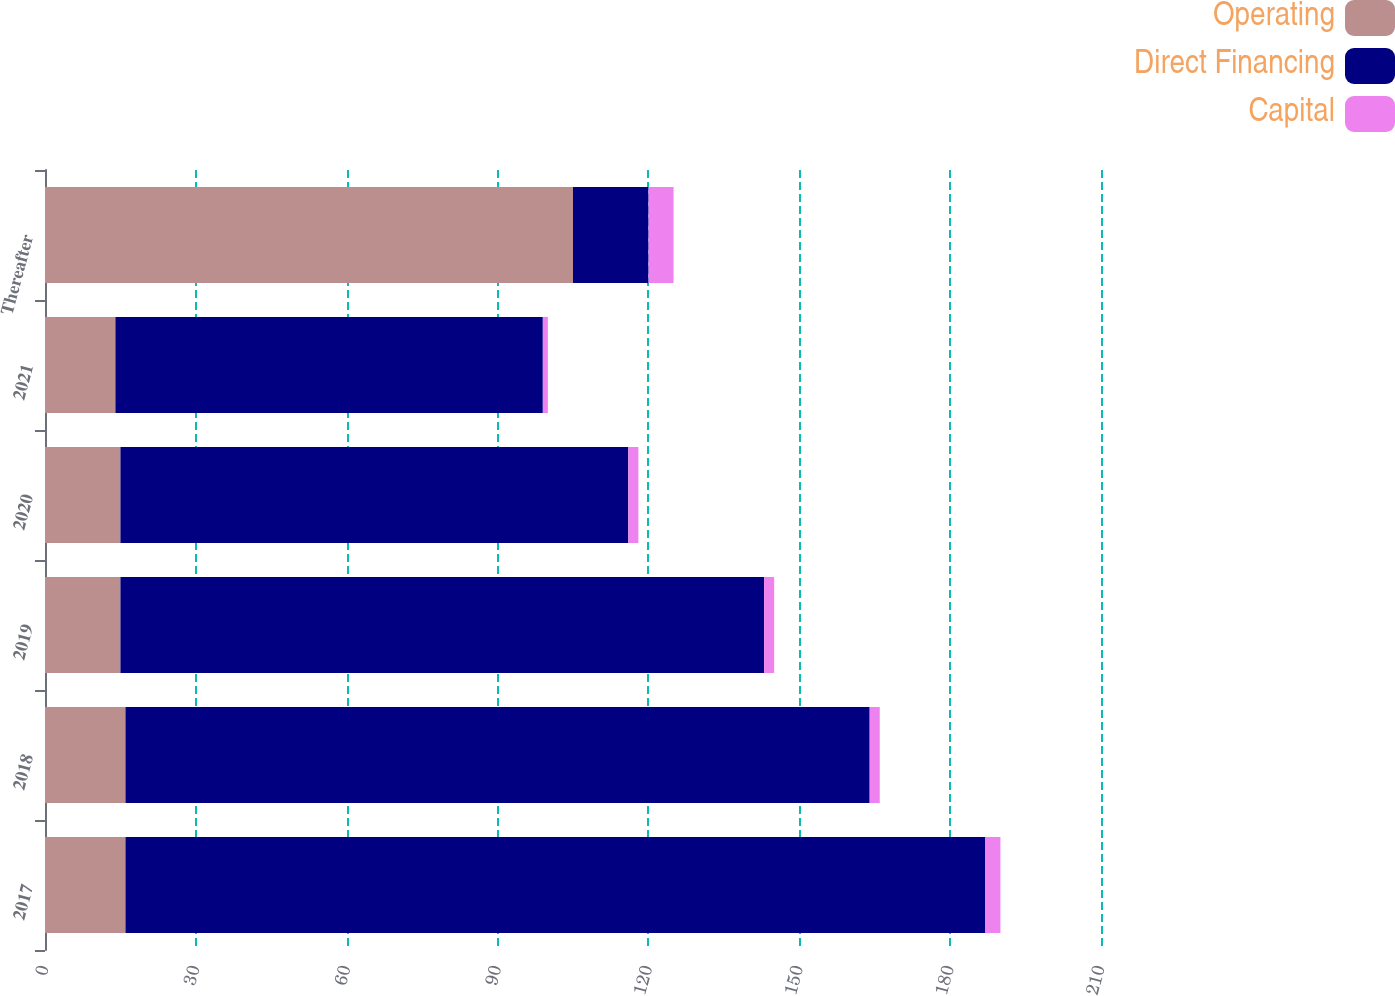<chart> <loc_0><loc_0><loc_500><loc_500><stacked_bar_chart><ecel><fcel>2017<fcel>2018<fcel>2019<fcel>2020<fcel>2021<fcel>Thereafter<nl><fcel>Operating<fcel>16<fcel>16<fcel>15<fcel>15<fcel>14<fcel>105<nl><fcel>Direct Financing<fcel>171<fcel>148<fcel>128<fcel>101<fcel>85<fcel>15<nl><fcel>Capital<fcel>3<fcel>2<fcel>2<fcel>2<fcel>1<fcel>5<nl></chart> 